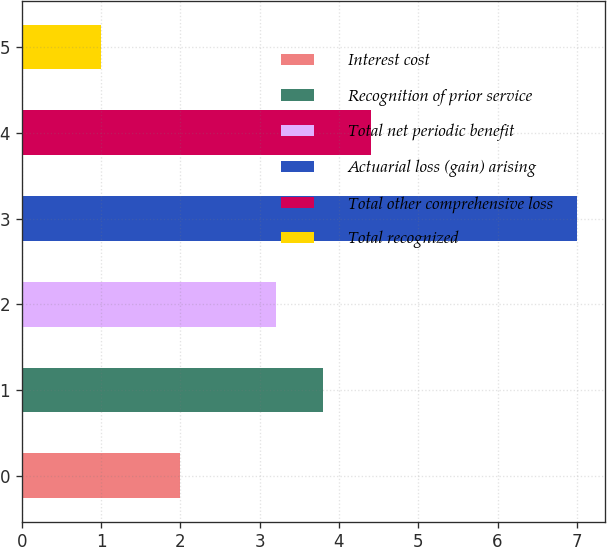<chart> <loc_0><loc_0><loc_500><loc_500><bar_chart><fcel>Interest cost<fcel>Recognition of prior service<fcel>Total net periodic benefit<fcel>Actuarial loss (gain) arising<fcel>Total other comprehensive loss<fcel>Total recognized<nl><fcel>2<fcel>3.8<fcel>3.2<fcel>7<fcel>4.4<fcel>1<nl></chart> 